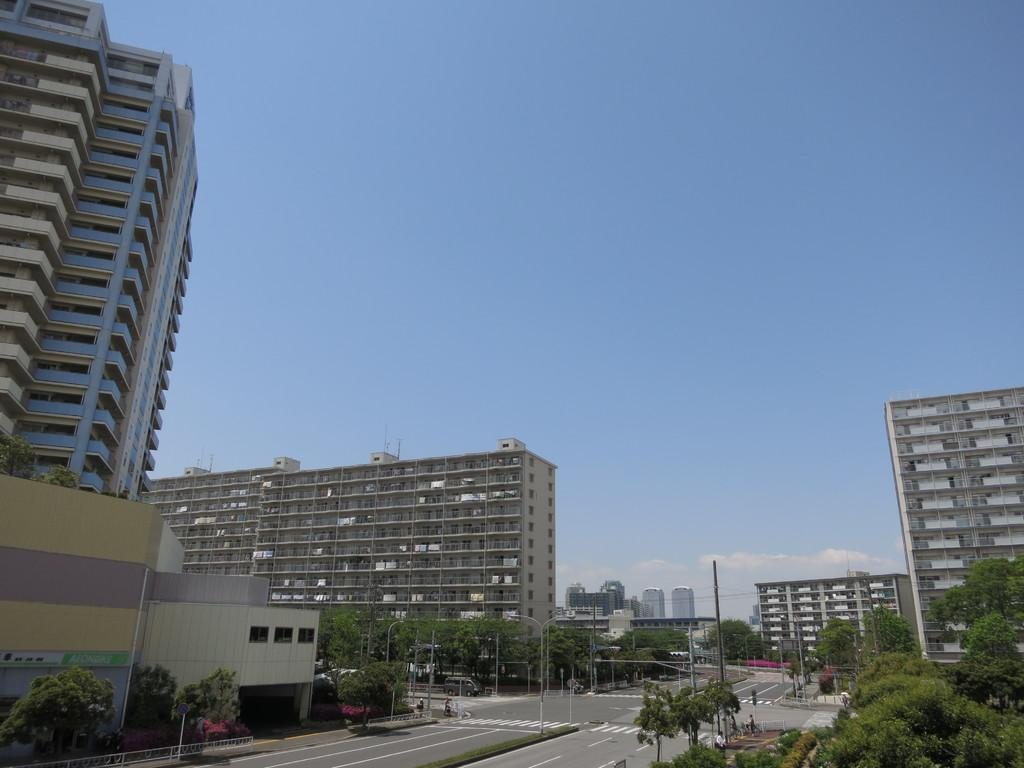What type of structures can be seen in the image? There are buildings in the image. What other natural elements are present in the image? There are trees in the image. What mode of transportation can be seen on the road in the image? There is a vehicle on the road in the image. What type of lighting is present in the image? Street lights are present in the image. What else can be seen in the image that is related to infrastructure? There is a pole with wires in the image. What can be seen in the background of the image? The sky is visible in the background of the image. What type of brush is used to clean the base of the buildings in the image? There is no brush or cleaning activity depicted in the image; it only shows buildings, trees, a vehicle, street lights, a pole with wires, and the sky. Who gave approval for the construction of the buildings in the image? There is no information about the approval process for the construction of the buildings in the image. 